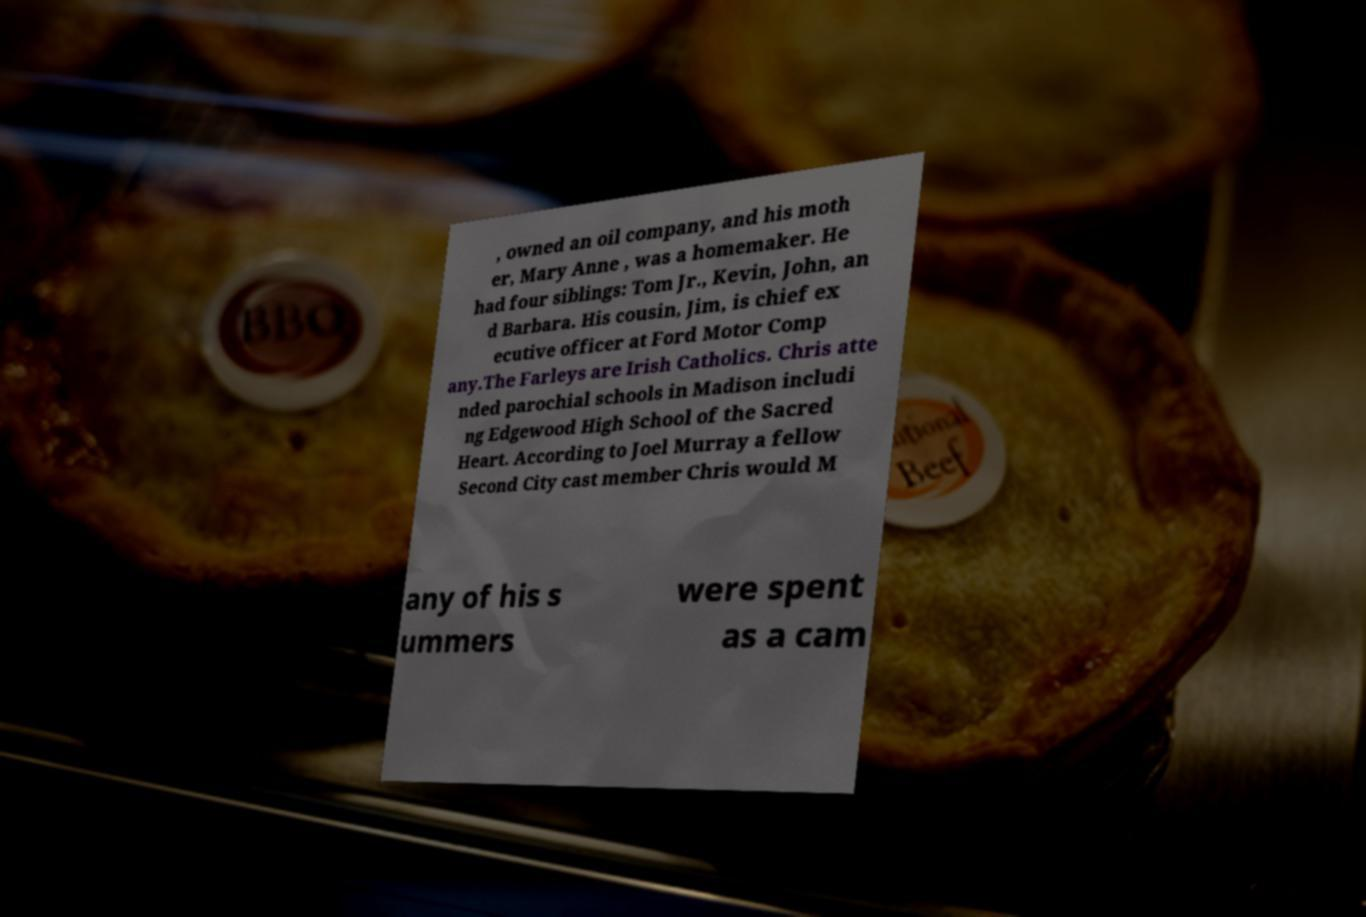Can you accurately transcribe the text from the provided image for me? , owned an oil company, and his moth er, Mary Anne , was a homemaker. He had four siblings: Tom Jr., Kevin, John, an d Barbara. His cousin, Jim, is chief ex ecutive officer at Ford Motor Comp any.The Farleys are Irish Catholics. Chris atte nded parochial schools in Madison includi ng Edgewood High School of the Sacred Heart. According to Joel Murray a fellow Second City cast member Chris would M any of his s ummers were spent as a cam 